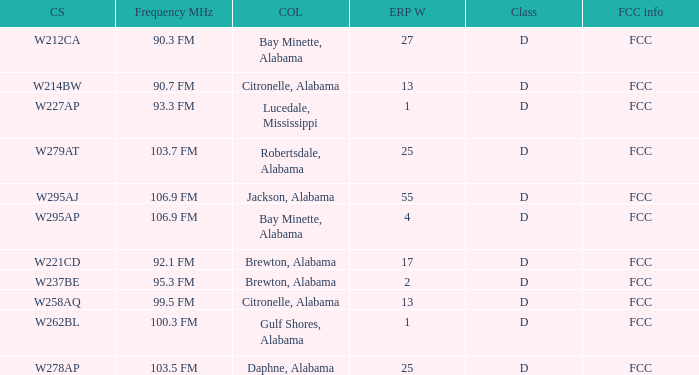Tell me the city of license with frequency of Mhz of 90.3 fm Bay Minette, Alabama. 